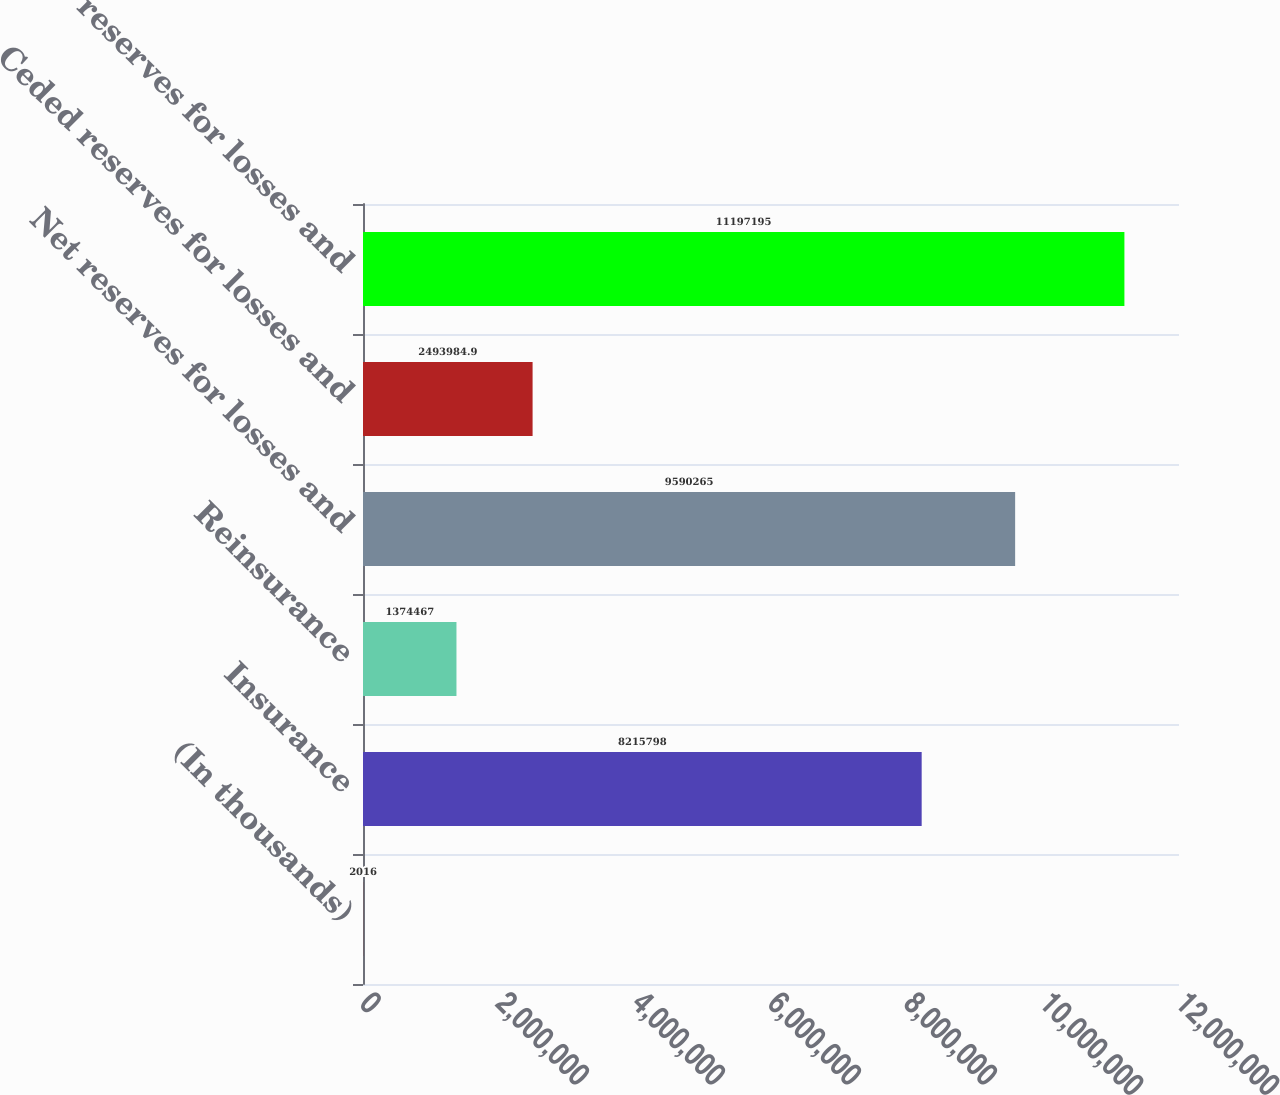Convert chart to OTSL. <chart><loc_0><loc_0><loc_500><loc_500><bar_chart><fcel>(In thousands)<fcel>Insurance<fcel>Reinsurance<fcel>Net reserves for losses and<fcel>Ceded reserves for losses and<fcel>Gross reserves for losses and<nl><fcel>2016<fcel>8.2158e+06<fcel>1.37447e+06<fcel>9.59026e+06<fcel>2.49398e+06<fcel>1.11972e+07<nl></chart> 